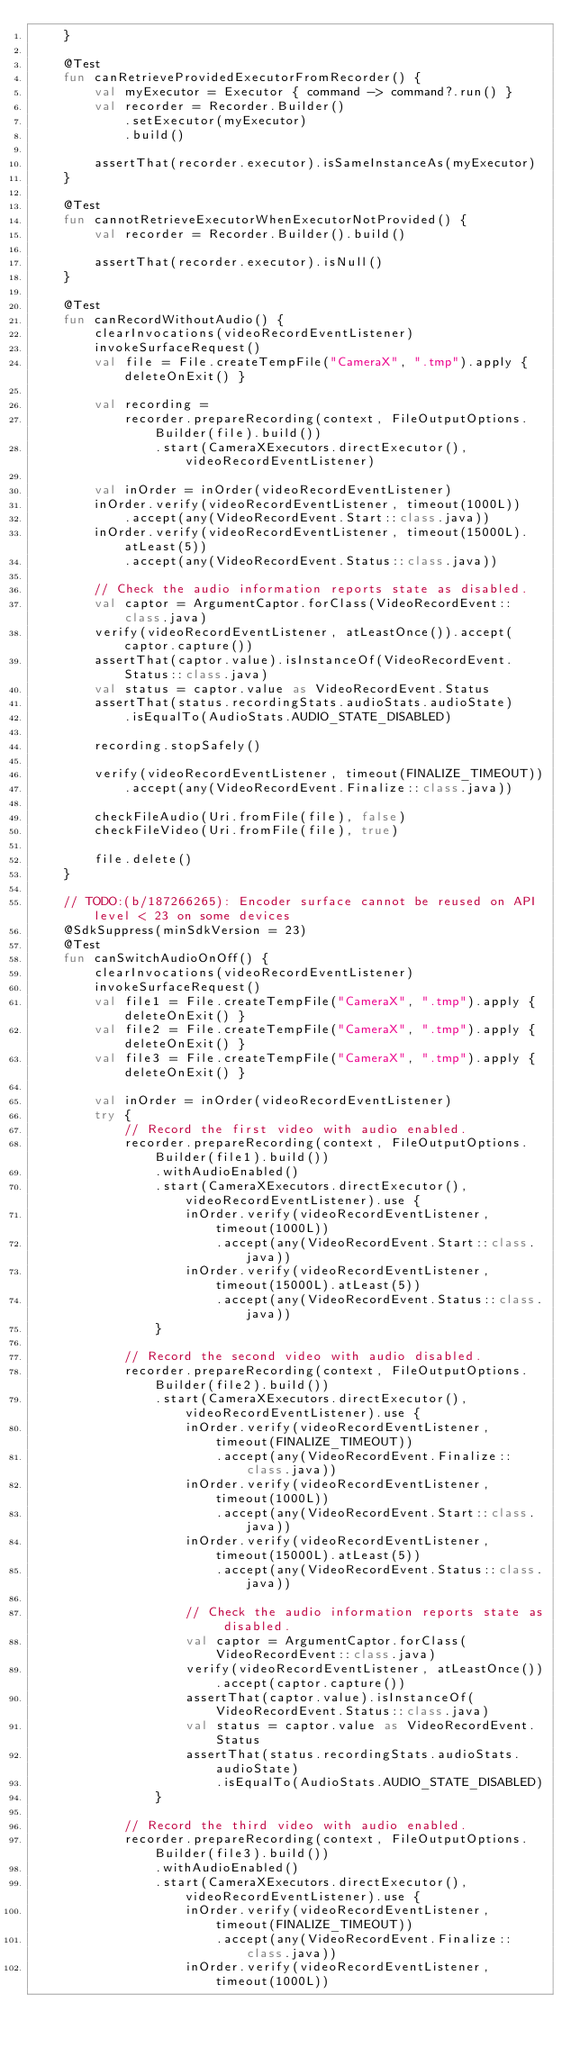<code> <loc_0><loc_0><loc_500><loc_500><_Kotlin_>    }

    @Test
    fun canRetrieveProvidedExecutorFromRecorder() {
        val myExecutor = Executor { command -> command?.run() }
        val recorder = Recorder.Builder()
            .setExecutor(myExecutor)
            .build()

        assertThat(recorder.executor).isSameInstanceAs(myExecutor)
    }

    @Test
    fun cannotRetrieveExecutorWhenExecutorNotProvided() {
        val recorder = Recorder.Builder().build()

        assertThat(recorder.executor).isNull()
    }

    @Test
    fun canRecordWithoutAudio() {
        clearInvocations(videoRecordEventListener)
        invokeSurfaceRequest()
        val file = File.createTempFile("CameraX", ".tmp").apply { deleteOnExit() }

        val recording =
            recorder.prepareRecording(context, FileOutputOptions.Builder(file).build())
                .start(CameraXExecutors.directExecutor(), videoRecordEventListener)

        val inOrder = inOrder(videoRecordEventListener)
        inOrder.verify(videoRecordEventListener, timeout(1000L))
            .accept(any(VideoRecordEvent.Start::class.java))
        inOrder.verify(videoRecordEventListener, timeout(15000L).atLeast(5))
            .accept(any(VideoRecordEvent.Status::class.java))

        // Check the audio information reports state as disabled.
        val captor = ArgumentCaptor.forClass(VideoRecordEvent::class.java)
        verify(videoRecordEventListener, atLeastOnce()).accept(captor.capture())
        assertThat(captor.value).isInstanceOf(VideoRecordEvent.Status::class.java)
        val status = captor.value as VideoRecordEvent.Status
        assertThat(status.recordingStats.audioStats.audioState)
            .isEqualTo(AudioStats.AUDIO_STATE_DISABLED)

        recording.stopSafely()

        verify(videoRecordEventListener, timeout(FINALIZE_TIMEOUT))
            .accept(any(VideoRecordEvent.Finalize::class.java))

        checkFileAudio(Uri.fromFile(file), false)
        checkFileVideo(Uri.fromFile(file), true)

        file.delete()
    }

    // TODO:(b/187266265): Encoder surface cannot be reused on API level < 23 on some devices
    @SdkSuppress(minSdkVersion = 23)
    @Test
    fun canSwitchAudioOnOff() {
        clearInvocations(videoRecordEventListener)
        invokeSurfaceRequest()
        val file1 = File.createTempFile("CameraX", ".tmp").apply { deleteOnExit() }
        val file2 = File.createTempFile("CameraX", ".tmp").apply { deleteOnExit() }
        val file3 = File.createTempFile("CameraX", ".tmp").apply { deleteOnExit() }

        val inOrder = inOrder(videoRecordEventListener)
        try {
            // Record the first video with audio enabled.
            recorder.prepareRecording(context, FileOutputOptions.Builder(file1).build())
                .withAudioEnabled()
                .start(CameraXExecutors.directExecutor(), videoRecordEventListener).use {
                    inOrder.verify(videoRecordEventListener, timeout(1000L))
                        .accept(any(VideoRecordEvent.Start::class.java))
                    inOrder.verify(videoRecordEventListener, timeout(15000L).atLeast(5))
                        .accept(any(VideoRecordEvent.Status::class.java))
                }

            // Record the second video with audio disabled.
            recorder.prepareRecording(context, FileOutputOptions.Builder(file2).build())
                .start(CameraXExecutors.directExecutor(), videoRecordEventListener).use {
                    inOrder.verify(videoRecordEventListener, timeout(FINALIZE_TIMEOUT))
                        .accept(any(VideoRecordEvent.Finalize::class.java))
                    inOrder.verify(videoRecordEventListener, timeout(1000L))
                        .accept(any(VideoRecordEvent.Start::class.java))
                    inOrder.verify(videoRecordEventListener, timeout(15000L).atLeast(5))
                        .accept(any(VideoRecordEvent.Status::class.java))

                    // Check the audio information reports state as disabled.
                    val captor = ArgumentCaptor.forClass(VideoRecordEvent::class.java)
                    verify(videoRecordEventListener, atLeastOnce()).accept(captor.capture())
                    assertThat(captor.value).isInstanceOf(VideoRecordEvent.Status::class.java)
                    val status = captor.value as VideoRecordEvent.Status
                    assertThat(status.recordingStats.audioStats.audioState)
                        .isEqualTo(AudioStats.AUDIO_STATE_DISABLED)
                }

            // Record the third video with audio enabled.
            recorder.prepareRecording(context, FileOutputOptions.Builder(file3).build())
                .withAudioEnabled()
                .start(CameraXExecutors.directExecutor(), videoRecordEventListener).use {
                    inOrder.verify(videoRecordEventListener, timeout(FINALIZE_TIMEOUT))
                        .accept(any(VideoRecordEvent.Finalize::class.java))
                    inOrder.verify(videoRecordEventListener, timeout(1000L))</code> 